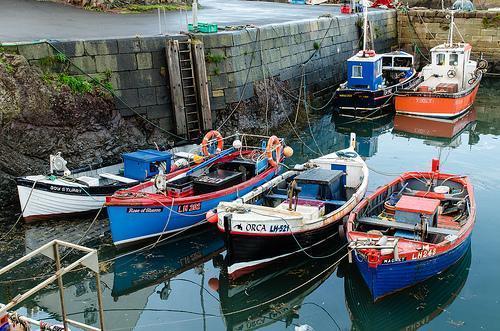How many boats are orange?
Give a very brief answer. 1. 